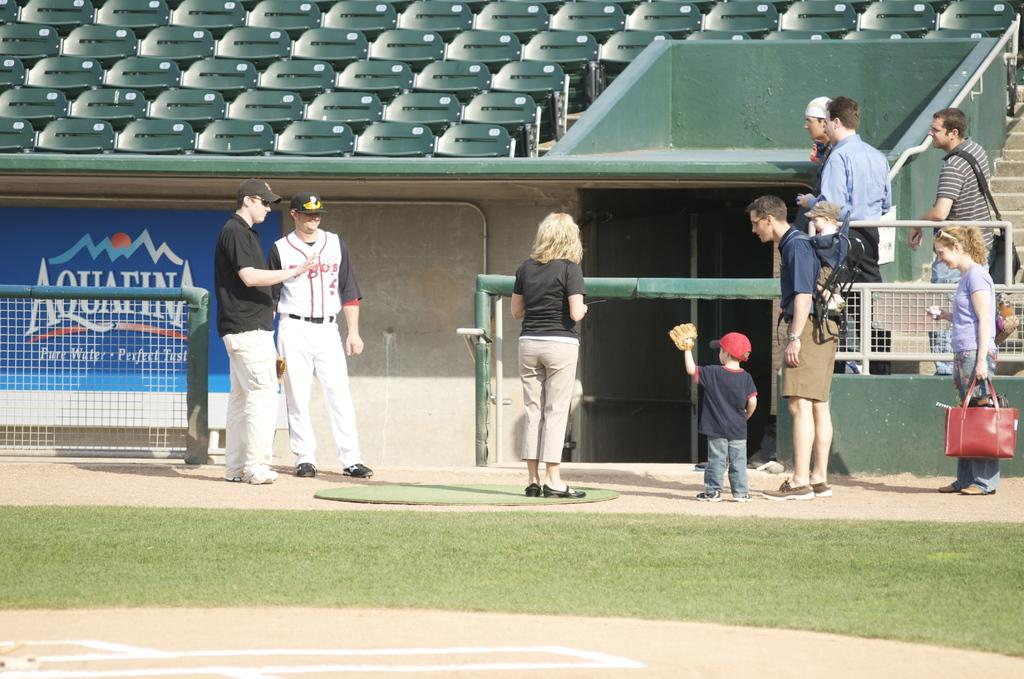<image>
Summarize the visual content of the image. Some men, women and a child hang out on a baseball diamond with an Aquafina ad behind them. 